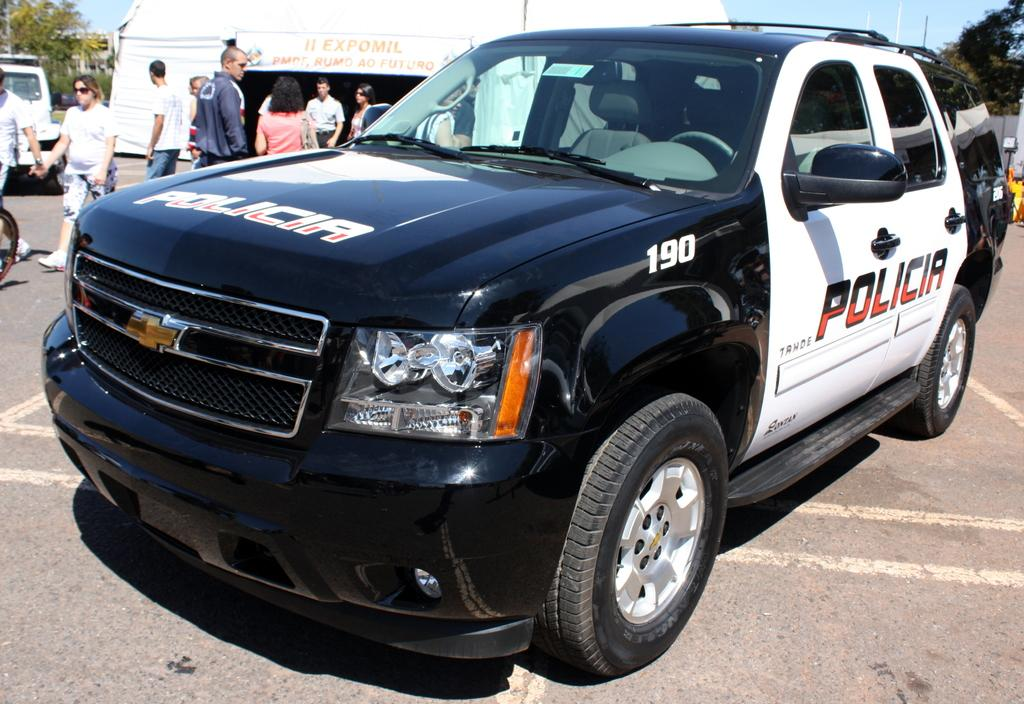What type of vehicle is present in the image? There is a police car in the image. What are the people in the image doing? There are people walking and standing in the image. What type of temporary shelter is visible in the image? There is a tent in the image. What type of vegetation is present in the image? There are trees in the image. What is the color of the sky in the image? The sky is blue in the image. Is there any other vehicle present in the image? Yes, there is a vehicle parked on the side of the image. What is the size of the bears in the image? There are no bears present in the image. What scent can be detected from the trees in the image? The image does not provide information about the scent of the trees. 